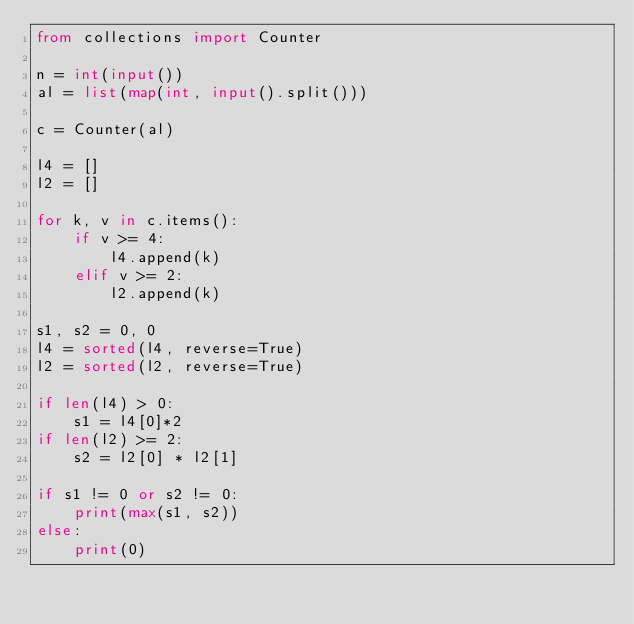Convert code to text. <code><loc_0><loc_0><loc_500><loc_500><_Python_>from collections import Counter

n = int(input())
al = list(map(int, input().split()))

c = Counter(al)

l4 = []
l2 = []

for k, v in c.items():
    if v >= 4:
        l4.append(k)
    elif v >= 2:
        l2.append(k)

s1, s2 = 0, 0
l4 = sorted(l4, reverse=True)
l2 = sorted(l2, reverse=True)

if len(l4) > 0:
    s1 = l4[0]*2
if len(l2) >= 2:
    s2 = l2[0] * l2[1]

if s1 != 0 or s2 != 0:
    print(max(s1, s2))
else:
    print(0)</code> 